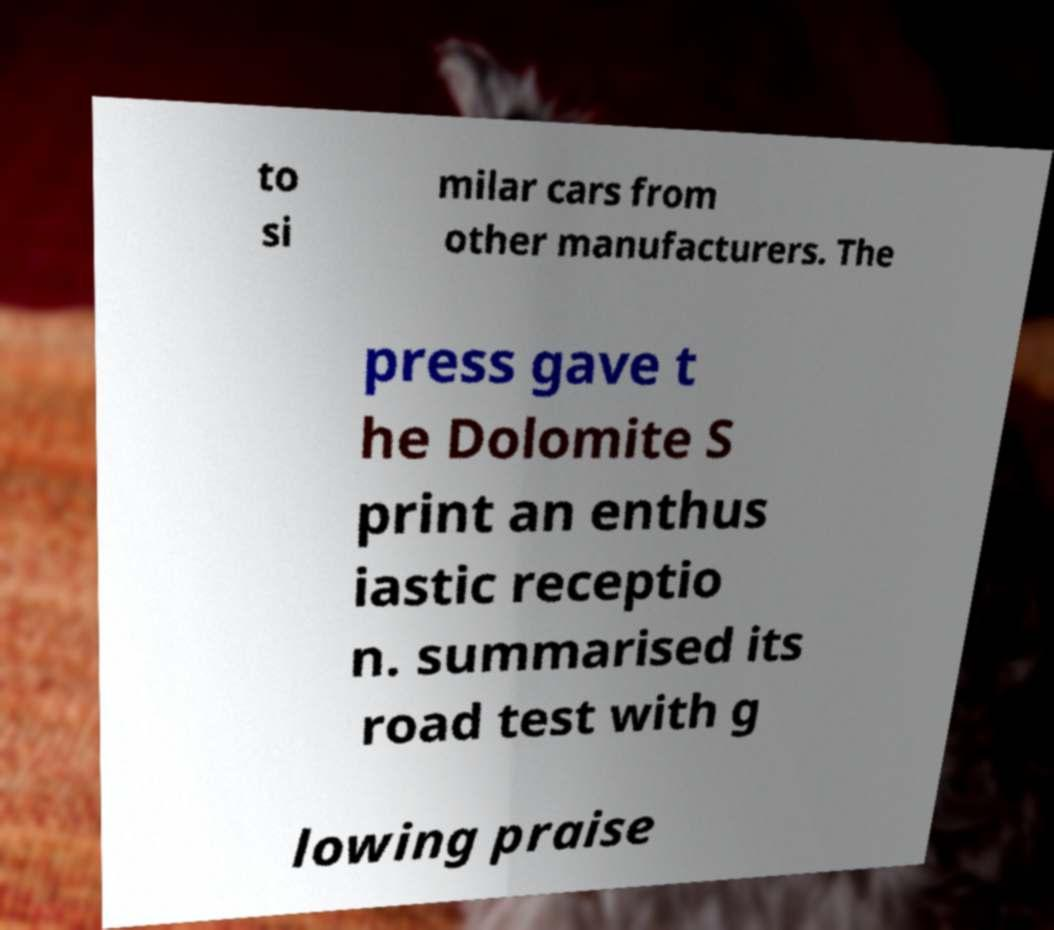What messages or text are displayed in this image? I need them in a readable, typed format. to si milar cars from other manufacturers. The press gave t he Dolomite S print an enthus iastic receptio n. summarised its road test with g lowing praise 